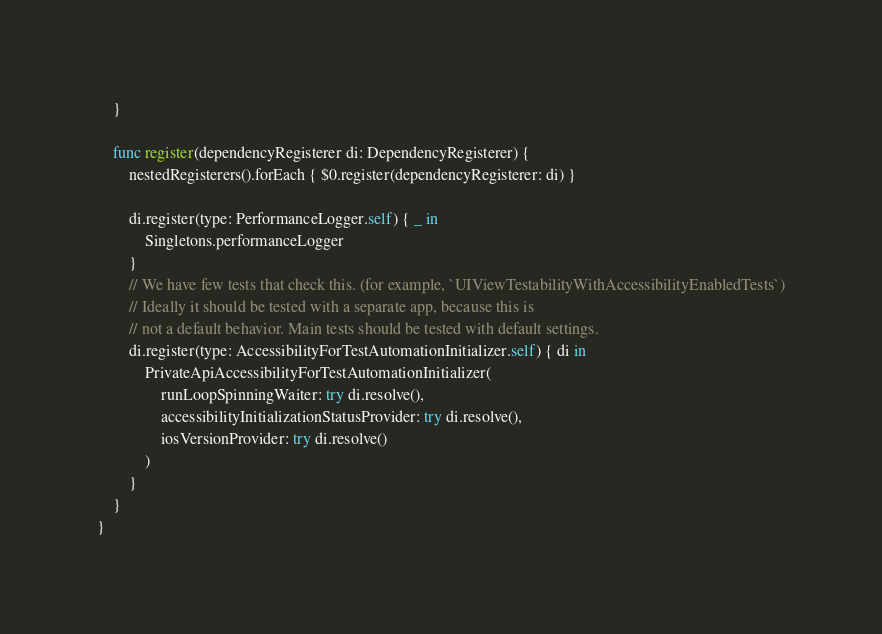Convert code to text. <code><loc_0><loc_0><loc_500><loc_500><_Swift_>    }
    
    func register(dependencyRegisterer di: DependencyRegisterer) {
        nestedRegisterers().forEach { $0.register(dependencyRegisterer: di) }
        
        di.register(type: PerformanceLogger.self) { _ in
            Singletons.performanceLogger
        }
        // We have few tests that check this. (for example, `UIViewTestabilityWithAccessibilityEnabledTests`)
        // Ideally it should be tested with a separate app, because this is
        // not a default behavior. Main tests should be tested with default settings.
        di.register(type: AccessibilityForTestAutomationInitializer.self) { di in
            PrivateApiAccessibilityForTestAutomationInitializer(
                runLoopSpinningWaiter: try di.resolve(),
                accessibilityInitializationStatusProvider: try di.resolve(),
                iosVersionProvider: try di.resolve()
            )
        }
    }
}
</code> 